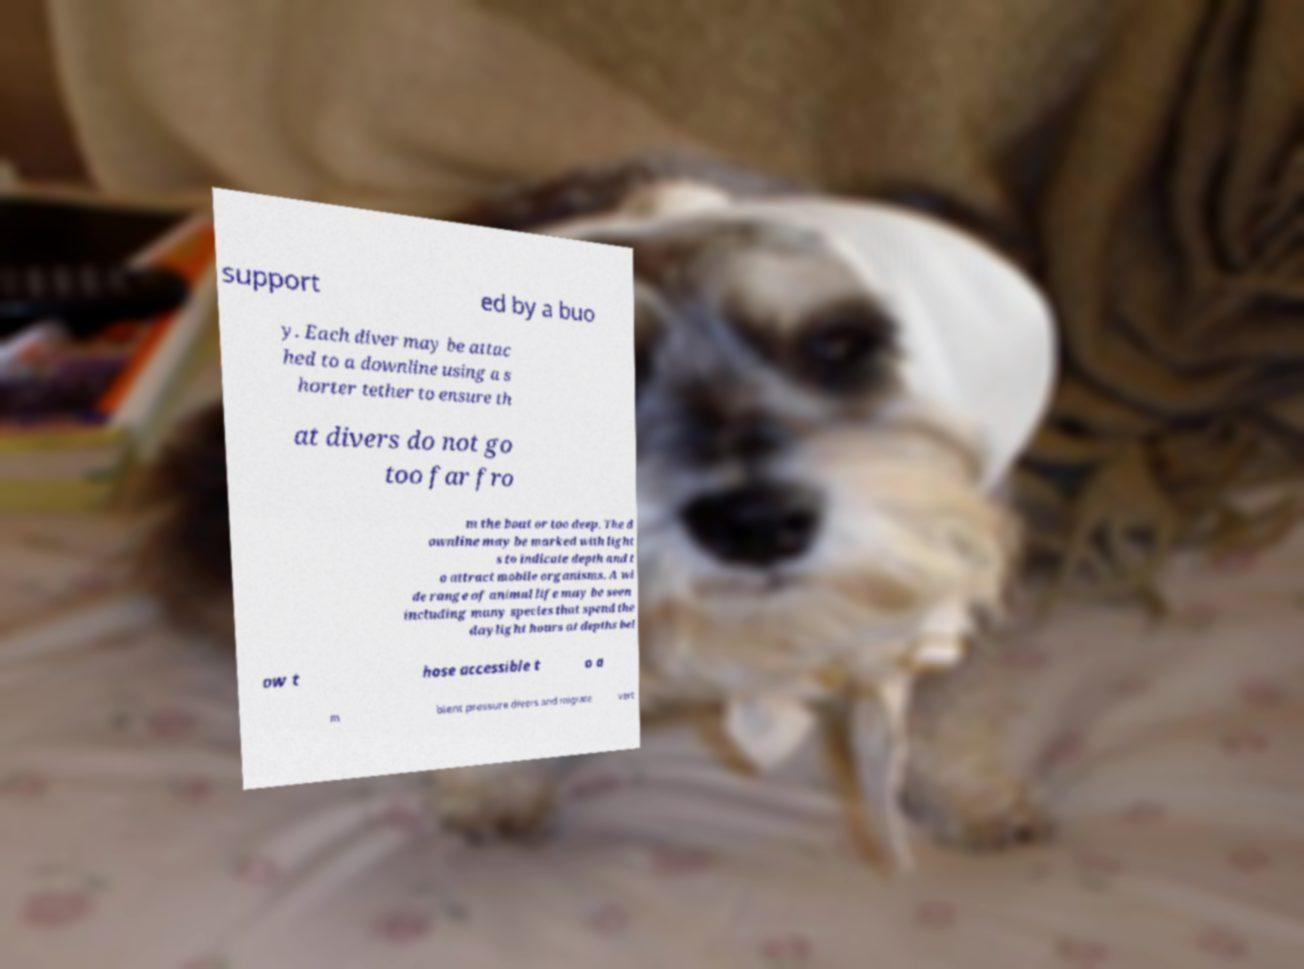There's text embedded in this image that I need extracted. Can you transcribe it verbatim? support ed by a buo y. Each diver may be attac hed to a downline using a s horter tether to ensure th at divers do not go too far fro m the boat or too deep. The d ownline may be marked with light s to indicate depth and t o attract mobile organisms. A wi de range of animal life may be seen including many species that spend the daylight hours at depths bel ow t hose accessible t o a m bient pressure divers and migrate vert 